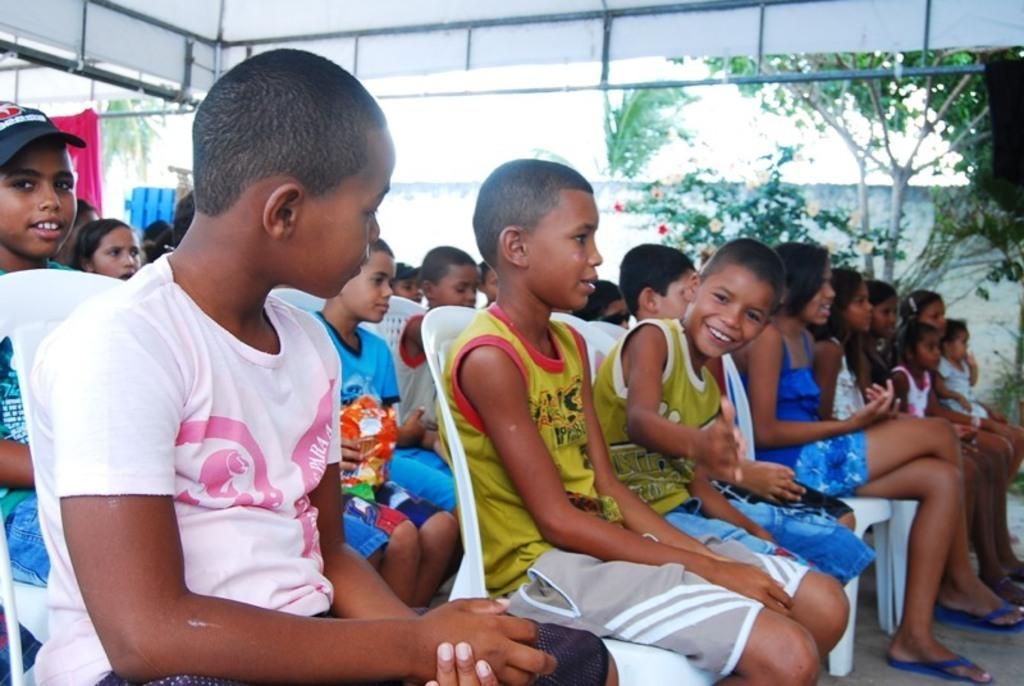What is the main subject of the image? The main subject of the image is a group of children. What are the children doing in the image? The children are sitting on chairs in the image. Where are the chairs placed? The chairs are placed on the floor. What can be seen in the background of the image? There is a group of trees, plants, a shed, and the sky visible in the background of the image. What type of property is on fire in the image? There is no property on fire in the image. What do you believe the children are discussing in the image? We cannot determine what the children are discussing in the image based on the provided facts. 